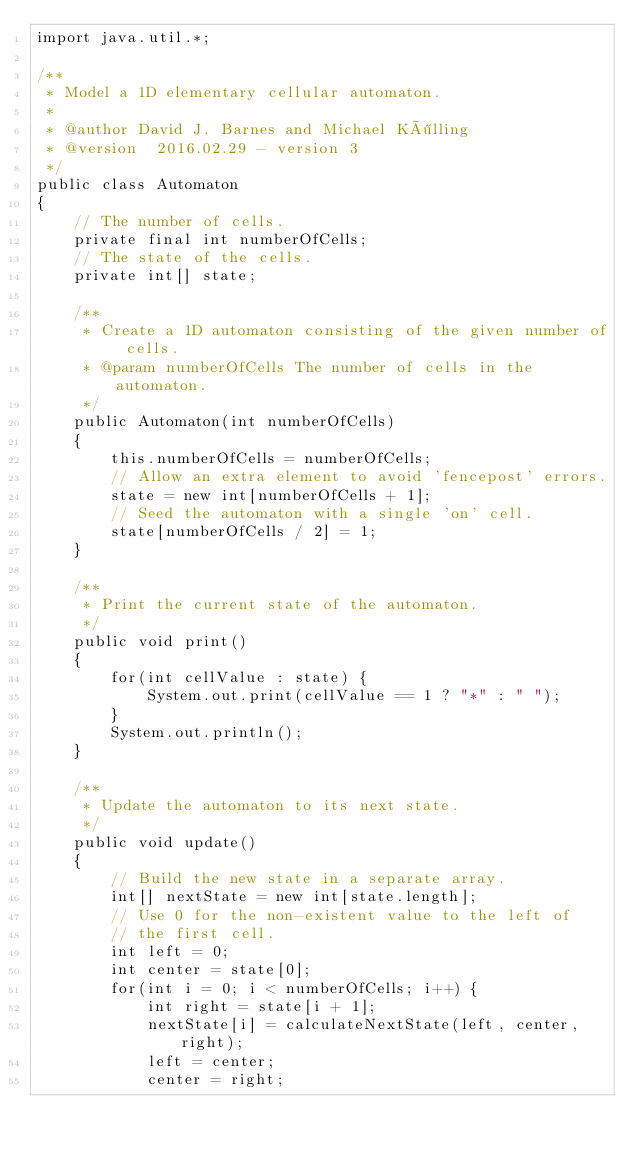Convert code to text. <code><loc_0><loc_0><loc_500><loc_500><_Java_>import java.util.*;

/**
 * Model a 1D elementary cellular automaton.
 * 
 * @author David J. Barnes and Michael Kölling
 * @version  2016.02.29 - version 3
 */
public class Automaton
{
    // The number of cells.
    private final int numberOfCells;
    // The state of the cells.
    private int[] state;
    
    /**
     * Create a 1D automaton consisting of the given number of cells.
     * @param numberOfCells The number of cells in the automaton.
     */
    public Automaton(int numberOfCells)
    {
        this.numberOfCells = numberOfCells;
        // Allow an extra element to avoid 'fencepost' errors.
        state = new int[numberOfCells + 1];
        // Seed the automaton with a single 'on' cell.
        state[numberOfCells / 2] = 1;
    }
    
    /**
     * Print the current state of the automaton.
     */
    public void print()
    {
        for(int cellValue : state) {
            System.out.print(cellValue == 1 ? "*" : " ");
        }
        System.out.println();
    }   
    
    /**
     * Update the automaton to its next state.
     */
    public void update()
    {
        // Build the new state in a separate array.
        int[] nextState = new int[state.length];
        // Use 0 for the non-existent value to the left of
        // the first cell.
        int left = 0;
        int center = state[0];
        for(int i = 0; i < numberOfCells; i++) {
            int right = state[i + 1];
            nextState[i] = calculateNextState(left, center, right);
            left = center;
            center = right;</code> 